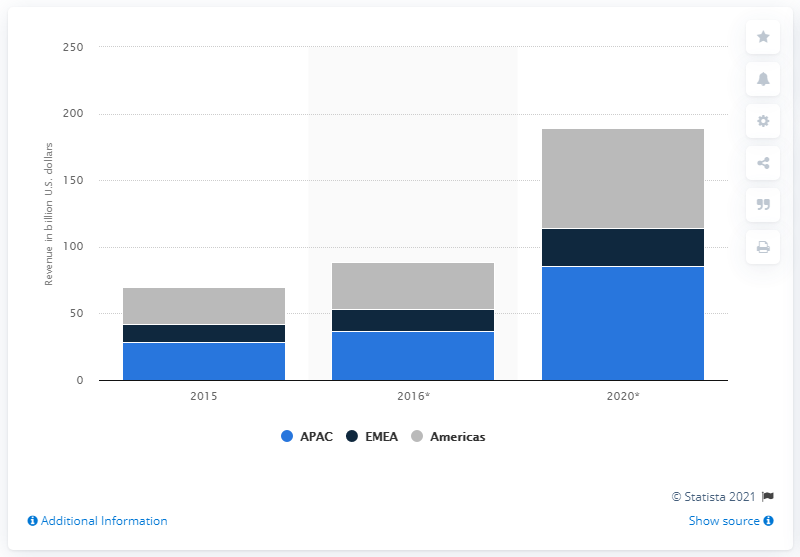Give some essential details in this illustration. Consumers in the Americas are expected to spend a substantial amount, approximately $74.5 billion, on mobile apps in 2020. In 2015, the amount of mobile net-to-publisher app revenues in the Americas was $27.4 million. 